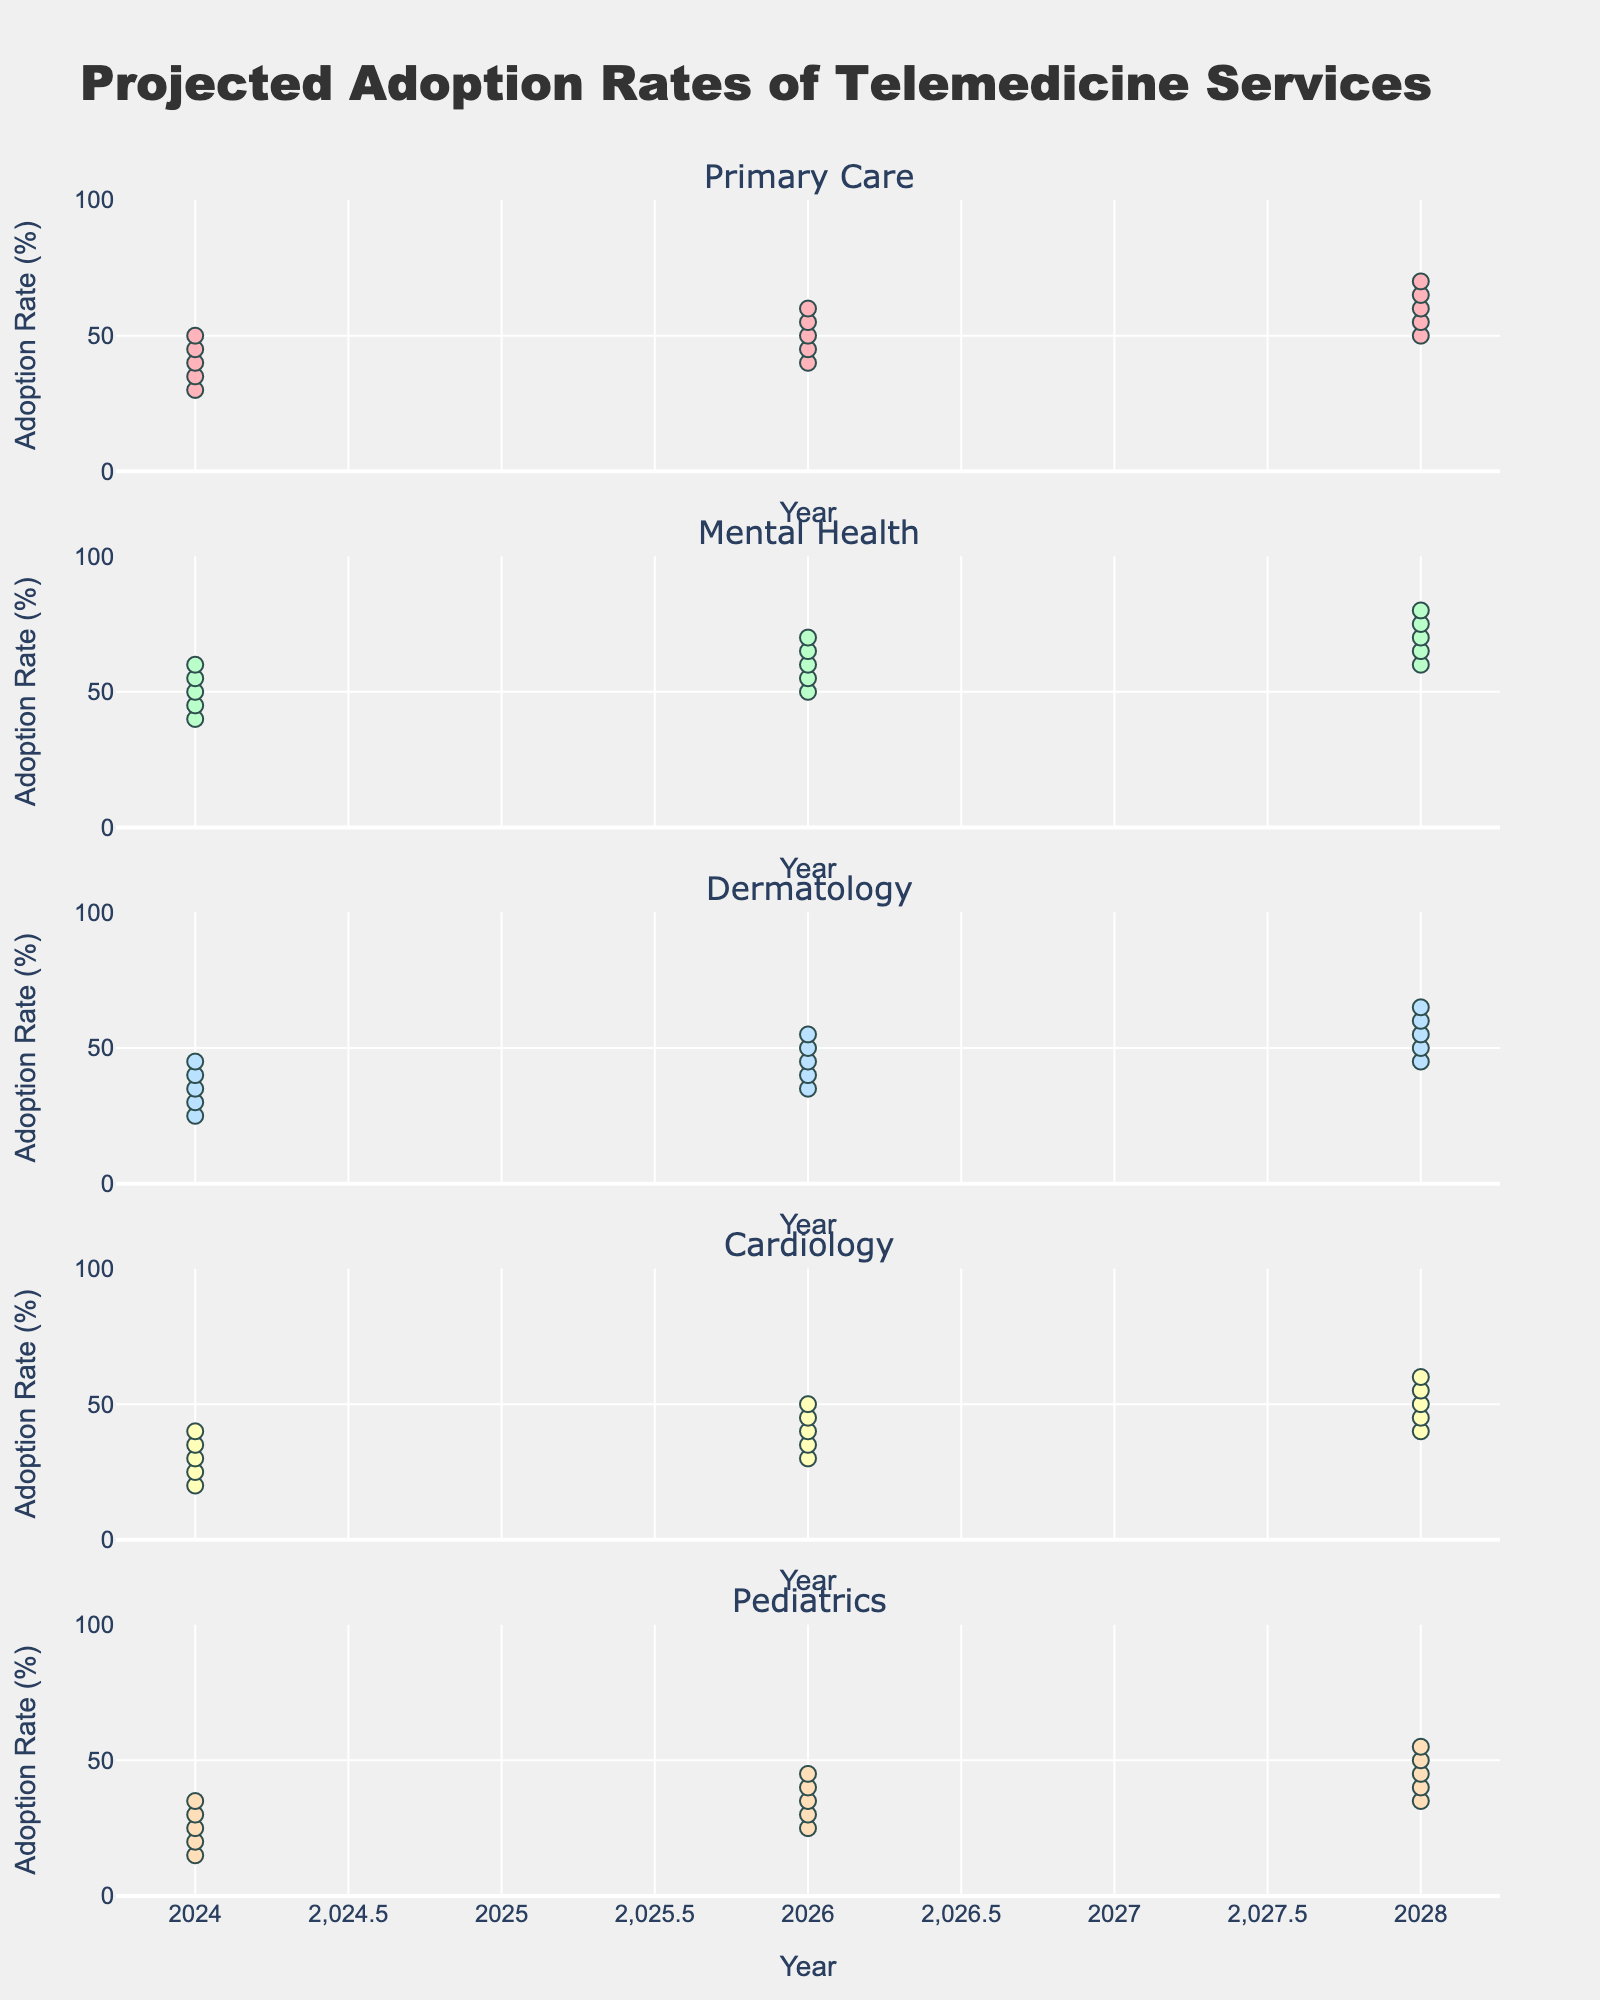What's the title of the figure? The title is typically located at the top of the figure. It is used to broadly describe the subject of the visualization. In this case, the title should describe the projected adoption rates of telemedicine across different medical fields.
Answer: Projected Adoption Rates of Telemedicine Services What is the projected mid-range adoption rate for Mental Health in 2026? Locate the Mental Health subplot, refer to the year 2026, and find the "Mid" value among Low, Low-Mid, Mid, Mid-High, and High.
Answer: 60% Which medical field has the highest projected adoption rate in 2028? Compare the highest values for each medical field in 2028. Identify the field with the maximum value.
Answer: Mental Health How does the adoption rate for Pediatrics in 2026 compare to that in 2028? Look at the Pediatrics subplot for both 2026 and 2028. Compare the median values (Mid) for both years. 2026: 35%, 2028: 45%. The 2028 value is higher.
Answer: The adoption rate is higher in 2028 What is the range of projected adoption rates for Cardiology in 2024? Locate the Cardiology subplot and refer to the year 2024. Identify the minimum (Low) and maximum (High) values.
Answer: 20% to 40% Which year shows the most significant increase in Primary Care adoption rates? Locate the Primary Care subplot. Compare the Mid values for each year and identify the year-to-year increase. 2024 - 2026: (50-40)=10, 2026 - 2028: (60-50)=10. Both show a similar increase.
Answer: 2024 to 2026 and 2026 to 2028 For Dermatology, what is the average of the Low and High values in 2028? Locate the Dermatology subplot, refer to the year 2028, and average the Low and High values. (45 + 65) / 2 = 55.
Answer: 55% In which medical field is the projected adoption rate range the narrowest in 2028? Compare the difference between High and Low values for each field in 2028. The narrowest range is for Pediatrics: 55-35=20.
Answer: Pediatrics Is the projected adoption rate for Cardiology more than 50% in 2028 at least one projection level? Locate the Cardiology subplot, refer to the values for 2028 and determine if any of them exceed 50%. The High value is 60%.
Answer: Yes How do the projected adoption rates for Pediatrics change from 2024 to 2028? Track the values for Pediatrics across the years 2024, 2026, and 2028. Identify any patterns or trends by comparing the Mid values. 25% (2024) < 35% (2026) < 45% (2028).
Answer: Increasing 